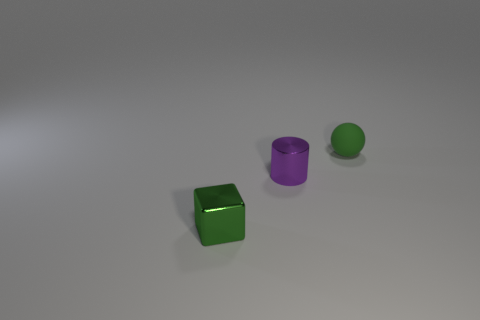Add 3 matte spheres. How many objects exist? 6 Subtract all cylinders. How many objects are left? 2 Add 3 small green balls. How many small green balls are left? 4 Add 2 yellow metal cylinders. How many yellow metal cylinders exist? 2 Subtract 0 red blocks. How many objects are left? 3 Subtract all green rubber spheres. Subtract all matte balls. How many objects are left? 1 